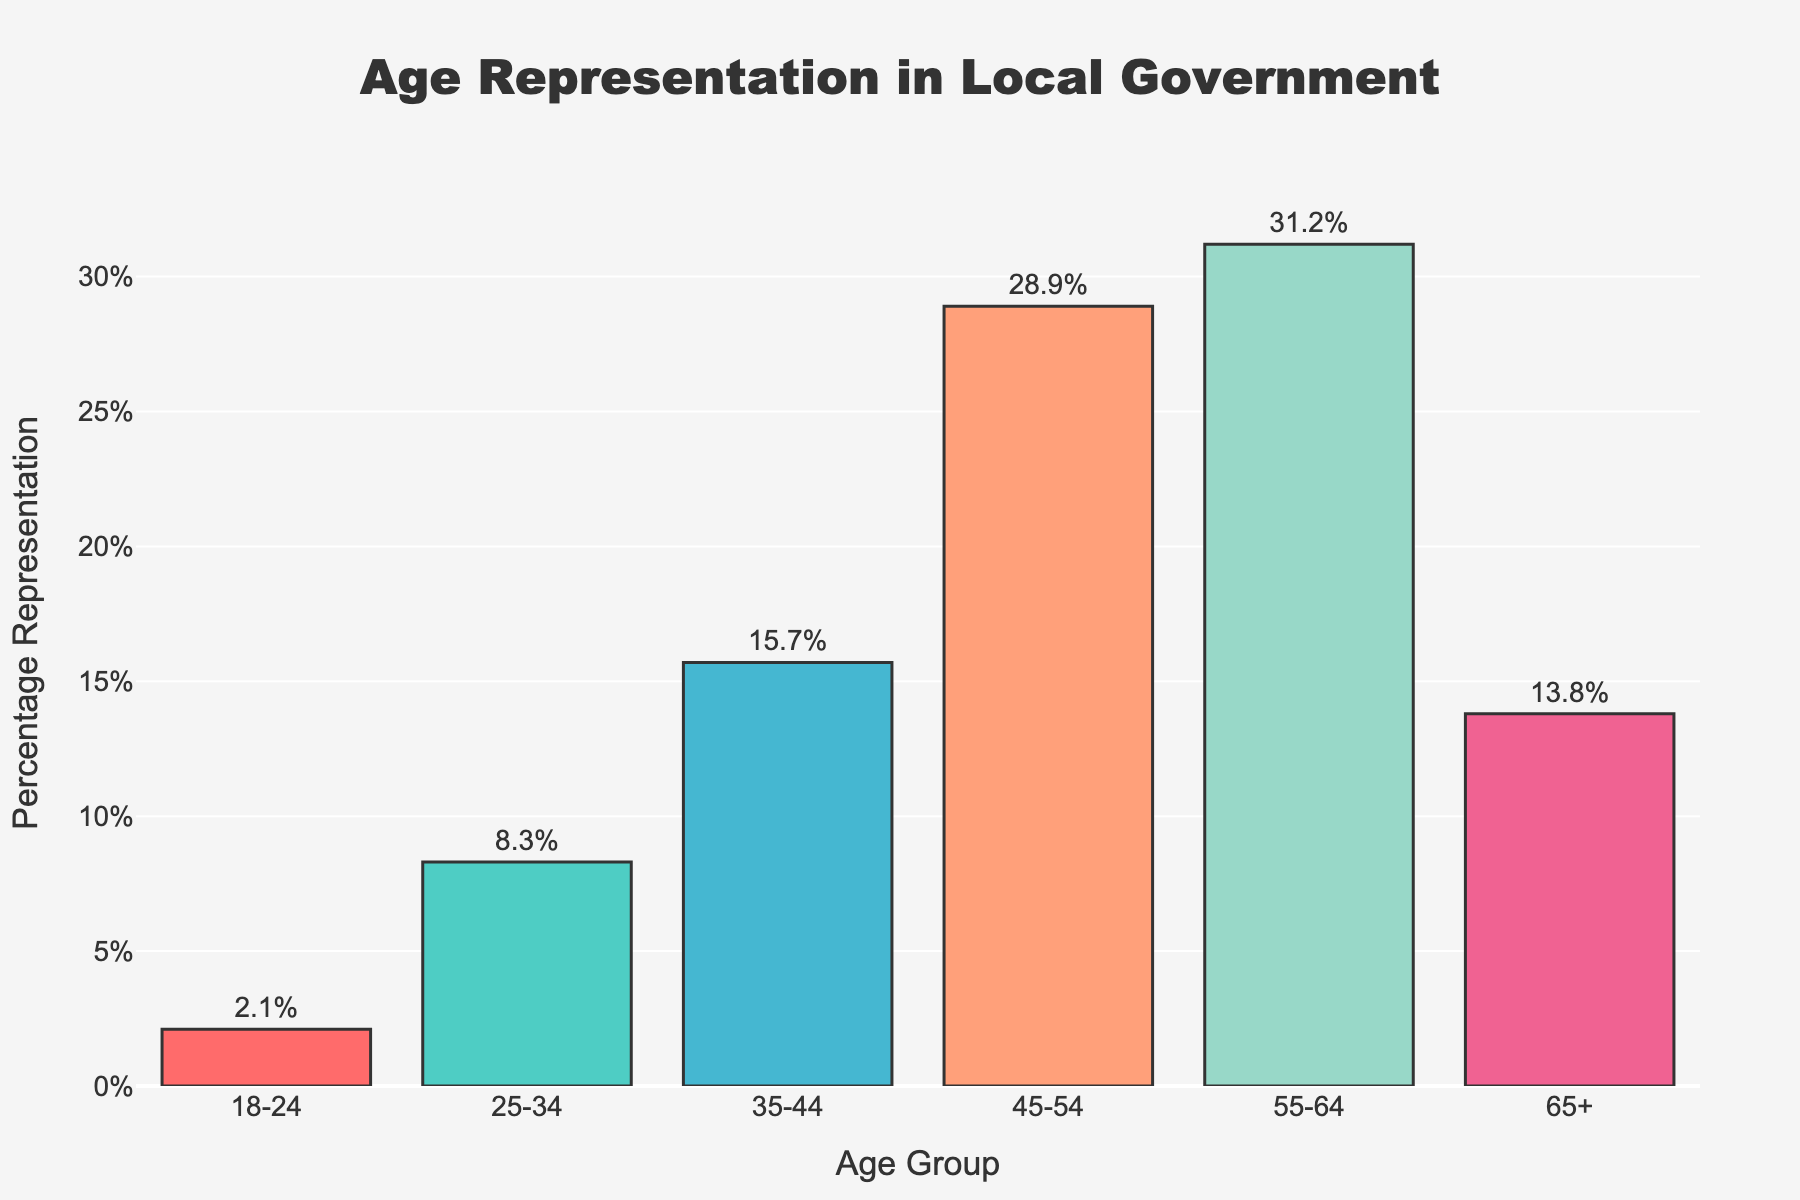What age group has the highest representation in local government? The bar chart shows that the age group with the highest percentage representation is 55-64 with a value of 31.2%.
Answer: 55-64 Which age group has the least representation in local government? By observing the shortest bar, the age group 18-24 has the lowest percentage representation at 2.1%.
Answer: 18-24 What is the combined representation percentage of the age groups below 35? Add the percentages of the age groups 18-24 (2.1%) and 25-34 (8.3%): 2.1 + 8.3 = 10.4%.
Answer: 10.4% How much more represented is the 55-64 age group compared to the 18-24 age group? Subtract the percentage of the 18-24 age group (2.1%) from the percentage of the 55-64 age group (31.2%): 31.2 - 2.1 = 29.1%.
Answer: 29.1% What's the total representation percentage of individuals aged 45 and above? Add the percentages of the age groups 45-54 (28.9%), 55-64 (31.2%), and 65+ (13.8%): 28.9 + 31.2 + 13.8 = 73.9%.
Answer: 73.9% Which age groups have a representation percentage within 5% of each other? The age groups 45-54 (28.9%) and 55-64 (31.2%) have a difference of 31.2 - 28.9 = 2.3%, which is within 5%.
Answer: 45-54 and 55-64 By how much does the representation of the 25-34 age group fall short of the 45-54 age group? Subtract the percentage of the 25-34 age group (8.3%) from the 45-54 age group (28.9%): 28.9 - 8.3 = 20.6%.
Answer: 20.6% Is the representation of the 65+ age group greater or lesser than that of the 35-44 age group? The 35-44 age group has a representation of 15.7%, while the 65+ age group has 13.8%. Hence, the representation of the 35-44 age group is greater.
Answer: Greater If the age groups 35-44 and 65+ are combined, what would their total representation be? Add the percentages of the age groups 35-44 (15.7%) and 65+ (13.8%): 15.7 + 13.8 = 29.5%.
Answer: 29.5% 